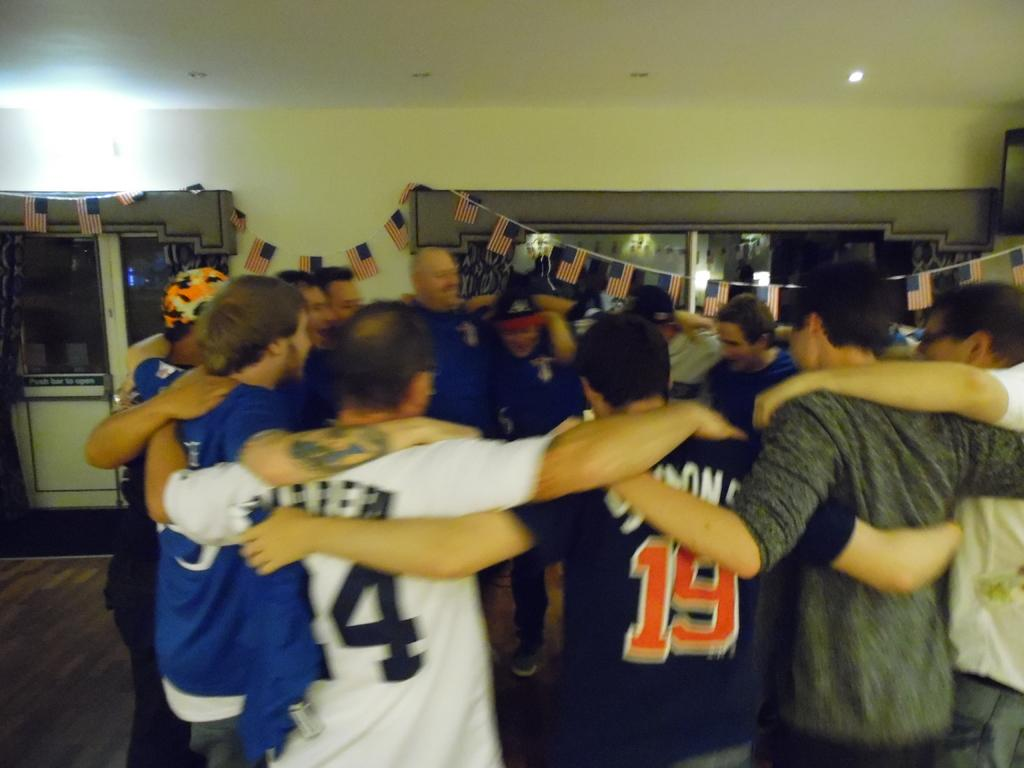Provide a one-sentence caption for the provided image. SPORTS TEAM PLAYERS IN A HUDDLE CELEBRATING, ONE WEARING THE NUMBER 19. 